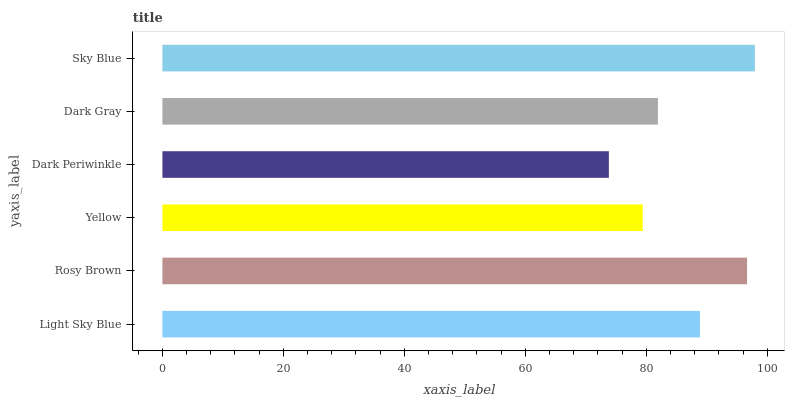Is Dark Periwinkle the minimum?
Answer yes or no. Yes. Is Sky Blue the maximum?
Answer yes or no. Yes. Is Rosy Brown the minimum?
Answer yes or no. No. Is Rosy Brown the maximum?
Answer yes or no. No. Is Rosy Brown greater than Light Sky Blue?
Answer yes or no. Yes. Is Light Sky Blue less than Rosy Brown?
Answer yes or no. Yes. Is Light Sky Blue greater than Rosy Brown?
Answer yes or no. No. Is Rosy Brown less than Light Sky Blue?
Answer yes or no. No. Is Light Sky Blue the high median?
Answer yes or no. Yes. Is Dark Gray the low median?
Answer yes or no. Yes. Is Dark Periwinkle the high median?
Answer yes or no. No. Is Yellow the low median?
Answer yes or no. No. 